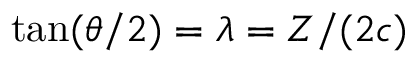Convert formula to latex. <formula><loc_0><loc_0><loc_500><loc_500>\tan ( \theta / 2 ) = { \lambda } = Z / ( 2 c )</formula> 